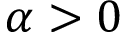Convert formula to latex. <formula><loc_0><loc_0><loc_500><loc_500>\alpha > 0</formula> 